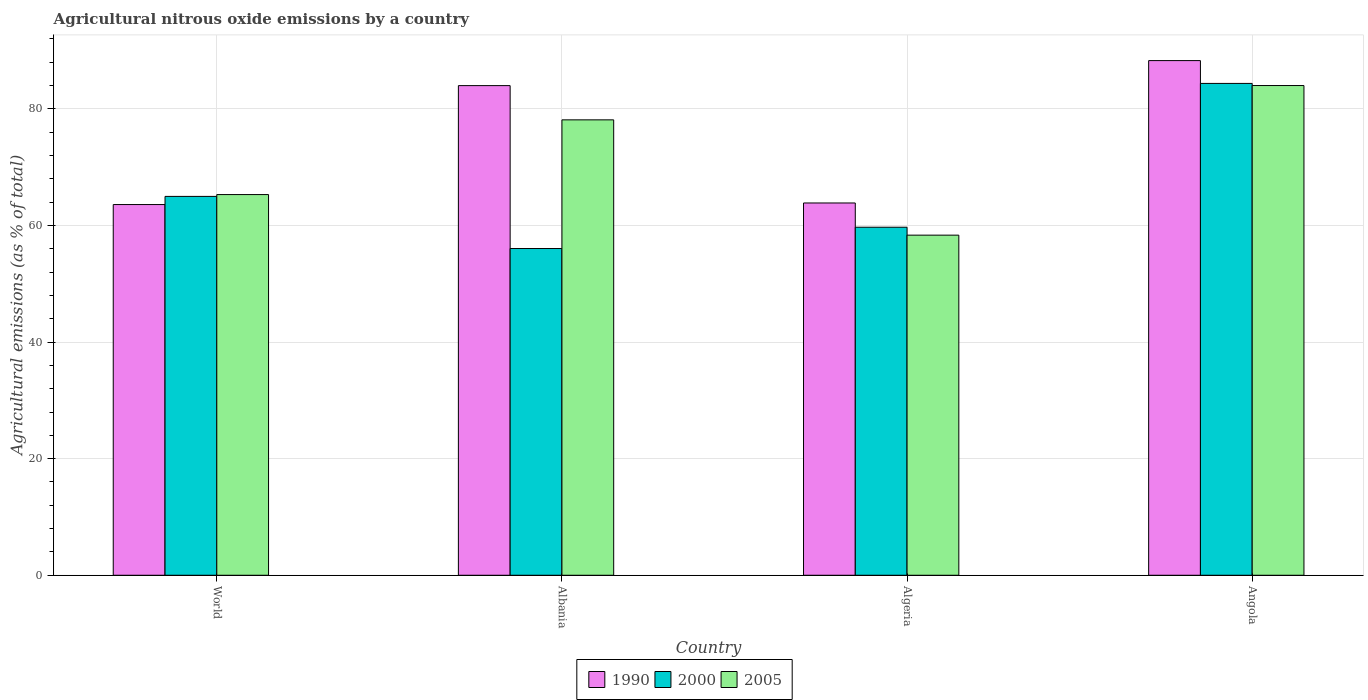How many different coloured bars are there?
Offer a terse response. 3. How many bars are there on the 4th tick from the left?
Provide a succinct answer. 3. What is the label of the 1st group of bars from the left?
Provide a short and direct response. World. What is the amount of agricultural nitrous oxide emitted in 2005 in World?
Make the answer very short. 65.29. Across all countries, what is the maximum amount of agricultural nitrous oxide emitted in 2005?
Provide a short and direct response. 83.99. Across all countries, what is the minimum amount of agricultural nitrous oxide emitted in 2000?
Provide a succinct answer. 56.04. In which country was the amount of agricultural nitrous oxide emitted in 1990 maximum?
Your answer should be compact. Angola. In which country was the amount of agricultural nitrous oxide emitted in 2005 minimum?
Provide a short and direct response. Algeria. What is the total amount of agricultural nitrous oxide emitted in 2000 in the graph?
Your answer should be compact. 265.07. What is the difference between the amount of agricultural nitrous oxide emitted in 2000 in Albania and that in Angola?
Give a very brief answer. -28.32. What is the difference between the amount of agricultural nitrous oxide emitted in 2005 in World and the amount of agricultural nitrous oxide emitted in 1990 in Albania?
Offer a terse response. -18.68. What is the average amount of agricultural nitrous oxide emitted in 2000 per country?
Provide a succinct answer. 66.27. What is the difference between the amount of agricultural nitrous oxide emitted of/in 2000 and amount of agricultural nitrous oxide emitted of/in 2005 in Algeria?
Offer a very short reply. 1.36. In how many countries, is the amount of agricultural nitrous oxide emitted in 2000 greater than 28 %?
Offer a terse response. 4. What is the ratio of the amount of agricultural nitrous oxide emitted in 1990 in Angola to that in World?
Provide a succinct answer. 1.39. What is the difference between the highest and the second highest amount of agricultural nitrous oxide emitted in 2005?
Make the answer very short. -18.7. What is the difference between the highest and the lowest amount of agricultural nitrous oxide emitted in 2000?
Ensure brevity in your answer.  28.32. In how many countries, is the amount of agricultural nitrous oxide emitted in 2005 greater than the average amount of agricultural nitrous oxide emitted in 2005 taken over all countries?
Your answer should be very brief. 2. Is it the case that in every country, the sum of the amount of agricultural nitrous oxide emitted in 2005 and amount of agricultural nitrous oxide emitted in 1990 is greater than the amount of agricultural nitrous oxide emitted in 2000?
Provide a succinct answer. Yes. Are all the bars in the graph horizontal?
Your answer should be compact. No. Are the values on the major ticks of Y-axis written in scientific E-notation?
Keep it short and to the point. No. How are the legend labels stacked?
Make the answer very short. Horizontal. What is the title of the graph?
Make the answer very short. Agricultural nitrous oxide emissions by a country. What is the label or title of the Y-axis?
Give a very brief answer. Agricultural emissions (as % of total). What is the Agricultural emissions (as % of total) in 1990 in World?
Make the answer very short. 63.58. What is the Agricultural emissions (as % of total) in 2000 in World?
Ensure brevity in your answer.  64.98. What is the Agricultural emissions (as % of total) in 2005 in World?
Give a very brief answer. 65.29. What is the Agricultural emissions (as % of total) in 1990 in Albania?
Offer a terse response. 83.98. What is the Agricultural emissions (as % of total) in 2000 in Albania?
Ensure brevity in your answer.  56.04. What is the Agricultural emissions (as % of total) of 2005 in Albania?
Make the answer very short. 78.11. What is the Agricultural emissions (as % of total) of 1990 in Algeria?
Make the answer very short. 63.85. What is the Agricultural emissions (as % of total) of 2000 in Algeria?
Ensure brevity in your answer.  59.69. What is the Agricultural emissions (as % of total) in 2005 in Algeria?
Offer a very short reply. 58.33. What is the Agricultural emissions (as % of total) of 1990 in Angola?
Your response must be concise. 88.27. What is the Agricultural emissions (as % of total) in 2000 in Angola?
Provide a succinct answer. 84.36. What is the Agricultural emissions (as % of total) in 2005 in Angola?
Provide a short and direct response. 83.99. Across all countries, what is the maximum Agricultural emissions (as % of total) in 1990?
Make the answer very short. 88.27. Across all countries, what is the maximum Agricultural emissions (as % of total) of 2000?
Your answer should be very brief. 84.36. Across all countries, what is the maximum Agricultural emissions (as % of total) in 2005?
Keep it short and to the point. 83.99. Across all countries, what is the minimum Agricultural emissions (as % of total) of 1990?
Provide a succinct answer. 63.58. Across all countries, what is the minimum Agricultural emissions (as % of total) of 2000?
Ensure brevity in your answer.  56.04. Across all countries, what is the minimum Agricultural emissions (as % of total) in 2005?
Your answer should be compact. 58.33. What is the total Agricultural emissions (as % of total) of 1990 in the graph?
Your response must be concise. 299.68. What is the total Agricultural emissions (as % of total) of 2000 in the graph?
Your answer should be compact. 265.07. What is the total Agricultural emissions (as % of total) of 2005 in the graph?
Ensure brevity in your answer.  285.73. What is the difference between the Agricultural emissions (as % of total) in 1990 in World and that in Albania?
Keep it short and to the point. -20.4. What is the difference between the Agricultural emissions (as % of total) of 2000 in World and that in Albania?
Make the answer very short. 8.94. What is the difference between the Agricultural emissions (as % of total) of 2005 in World and that in Albania?
Make the answer very short. -12.81. What is the difference between the Agricultural emissions (as % of total) of 1990 in World and that in Algeria?
Your response must be concise. -0.27. What is the difference between the Agricultural emissions (as % of total) in 2000 in World and that in Algeria?
Provide a succinct answer. 5.29. What is the difference between the Agricultural emissions (as % of total) of 2005 in World and that in Algeria?
Provide a succinct answer. 6.96. What is the difference between the Agricultural emissions (as % of total) of 1990 in World and that in Angola?
Give a very brief answer. -24.69. What is the difference between the Agricultural emissions (as % of total) in 2000 in World and that in Angola?
Keep it short and to the point. -19.38. What is the difference between the Agricultural emissions (as % of total) of 2005 in World and that in Angola?
Provide a short and direct response. -18.7. What is the difference between the Agricultural emissions (as % of total) of 1990 in Albania and that in Algeria?
Make the answer very short. 20.13. What is the difference between the Agricultural emissions (as % of total) in 2000 in Albania and that in Algeria?
Make the answer very short. -3.65. What is the difference between the Agricultural emissions (as % of total) in 2005 in Albania and that in Algeria?
Your answer should be compact. 19.77. What is the difference between the Agricultural emissions (as % of total) in 1990 in Albania and that in Angola?
Your response must be concise. -4.29. What is the difference between the Agricultural emissions (as % of total) of 2000 in Albania and that in Angola?
Make the answer very short. -28.32. What is the difference between the Agricultural emissions (as % of total) of 2005 in Albania and that in Angola?
Your answer should be very brief. -5.89. What is the difference between the Agricultural emissions (as % of total) in 1990 in Algeria and that in Angola?
Offer a very short reply. -24.42. What is the difference between the Agricultural emissions (as % of total) of 2000 in Algeria and that in Angola?
Offer a very short reply. -24.67. What is the difference between the Agricultural emissions (as % of total) of 2005 in Algeria and that in Angola?
Make the answer very short. -25.66. What is the difference between the Agricultural emissions (as % of total) of 1990 in World and the Agricultural emissions (as % of total) of 2000 in Albania?
Your response must be concise. 7.54. What is the difference between the Agricultural emissions (as % of total) in 1990 in World and the Agricultural emissions (as % of total) in 2005 in Albania?
Offer a terse response. -14.53. What is the difference between the Agricultural emissions (as % of total) of 2000 in World and the Agricultural emissions (as % of total) of 2005 in Albania?
Make the answer very short. -13.13. What is the difference between the Agricultural emissions (as % of total) of 1990 in World and the Agricultural emissions (as % of total) of 2000 in Algeria?
Provide a succinct answer. 3.89. What is the difference between the Agricultural emissions (as % of total) in 1990 in World and the Agricultural emissions (as % of total) in 2005 in Algeria?
Give a very brief answer. 5.25. What is the difference between the Agricultural emissions (as % of total) in 2000 in World and the Agricultural emissions (as % of total) in 2005 in Algeria?
Offer a terse response. 6.65. What is the difference between the Agricultural emissions (as % of total) in 1990 in World and the Agricultural emissions (as % of total) in 2000 in Angola?
Provide a succinct answer. -20.78. What is the difference between the Agricultural emissions (as % of total) of 1990 in World and the Agricultural emissions (as % of total) of 2005 in Angola?
Provide a succinct answer. -20.41. What is the difference between the Agricultural emissions (as % of total) in 2000 in World and the Agricultural emissions (as % of total) in 2005 in Angola?
Ensure brevity in your answer.  -19.01. What is the difference between the Agricultural emissions (as % of total) of 1990 in Albania and the Agricultural emissions (as % of total) of 2000 in Algeria?
Offer a terse response. 24.29. What is the difference between the Agricultural emissions (as % of total) of 1990 in Albania and the Agricultural emissions (as % of total) of 2005 in Algeria?
Keep it short and to the point. 25.65. What is the difference between the Agricultural emissions (as % of total) of 2000 in Albania and the Agricultural emissions (as % of total) of 2005 in Algeria?
Offer a terse response. -2.29. What is the difference between the Agricultural emissions (as % of total) in 1990 in Albania and the Agricultural emissions (as % of total) in 2000 in Angola?
Offer a terse response. -0.38. What is the difference between the Agricultural emissions (as % of total) of 1990 in Albania and the Agricultural emissions (as % of total) of 2005 in Angola?
Your answer should be very brief. -0.01. What is the difference between the Agricultural emissions (as % of total) in 2000 in Albania and the Agricultural emissions (as % of total) in 2005 in Angola?
Offer a terse response. -27.95. What is the difference between the Agricultural emissions (as % of total) of 1990 in Algeria and the Agricultural emissions (as % of total) of 2000 in Angola?
Your answer should be very brief. -20.51. What is the difference between the Agricultural emissions (as % of total) in 1990 in Algeria and the Agricultural emissions (as % of total) in 2005 in Angola?
Give a very brief answer. -20.14. What is the difference between the Agricultural emissions (as % of total) in 2000 in Algeria and the Agricultural emissions (as % of total) in 2005 in Angola?
Your response must be concise. -24.3. What is the average Agricultural emissions (as % of total) in 1990 per country?
Provide a succinct answer. 74.92. What is the average Agricultural emissions (as % of total) in 2000 per country?
Give a very brief answer. 66.27. What is the average Agricultural emissions (as % of total) in 2005 per country?
Give a very brief answer. 71.43. What is the difference between the Agricultural emissions (as % of total) of 1990 and Agricultural emissions (as % of total) of 2000 in World?
Provide a succinct answer. -1.4. What is the difference between the Agricultural emissions (as % of total) of 1990 and Agricultural emissions (as % of total) of 2005 in World?
Make the answer very short. -1.71. What is the difference between the Agricultural emissions (as % of total) of 2000 and Agricultural emissions (as % of total) of 2005 in World?
Your answer should be compact. -0.31. What is the difference between the Agricultural emissions (as % of total) in 1990 and Agricultural emissions (as % of total) in 2000 in Albania?
Provide a short and direct response. 27.94. What is the difference between the Agricultural emissions (as % of total) of 1990 and Agricultural emissions (as % of total) of 2005 in Albania?
Provide a short and direct response. 5.87. What is the difference between the Agricultural emissions (as % of total) in 2000 and Agricultural emissions (as % of total) in 2005 in Albania?
Provide a short and direct response. -22.07. What is the difference between the Agricultural emissions (as % of total) in 1990 and Agricultural emissions (as % of total) in 2000 in Algeria?
Keep it short and to the point. 4.16. What is the difference between the Agricultural emissions (as % of total) in 1990 and Agricultural emissions (as % of total) in 2005 in Algeria?
Your answer should be very brief. 5.52. What is the difference between the Agricultural emissions (as % of total) in 2000 and Agricultural emissions (as % of total) in 2005 in Algeria?
Give a very brief answer. 1.36. What is the difference between the Agricultural emissions (as % of total) in 1990 and Agricultural emissions (as % of total) in 2000 in Angola?
Provide a short and direct response. 3.91. What is the difference between the Agricultural emissions (as % of total) in 1990 and Agricultural emissions (as % of total) in 2005 in Angola?
Your answer should be compact. 4.28. What is the difference between the Agricultural emissions (as % of total) in 2000 and Agricultural emissions (as % of total) in 2005 in Angola?
Your answer should be very brief. 0.37. What is the ratio of the Agricultural emissions (as % of total) of 1990 in World to that in Albania?
Your answer should be compact. 0.76. What is the ratio of the Agricultural emissions (as % of total) of 2000 in World to that in Albania?
Make the answer very short. 1.16. What is the ratio of the Agricultural emissions (as % of total) of 2005 in World to that in Albania?
Your answer should be compact. 0.84. What is the ratio of the Agricultural emissions (as % of total) of 2000 in World to that in Algeria?
Your answer should be compact. 1.09. What is the ratio of the Agricultural emissions (as % of total) of 2005 in World to that in Algeria?
Provide a succinct answer. 1.12. What is the ratio of the Agricultural emissions (as % of total) in 1990 in World to that in Angola?
Your response must be concise. 0.72. What is the ratio of the Agricultural emissions (as % of total) in 2000 in World to that in Angola?
Provide a short and direct response. 0.77. What is the ratio of the Agricultural emissions (as % of total) in 2005 in World to that in Angola?
Provide a succinct answer. 0.78. What is the ratio of the Agricultural emissions (as % of total) of 1990 in Albania to that in Algeria?
Make the answer very short. 1.32. What is the ratio of the Agricultural emissions (as % of total) of 2000 in Albania to that in Algeria?
Your response must be concise. 0.94. What is the ratio of the Agricultural emissions (as % of total) in 2005 in Albania to that in Algeria?
Your response must be concise. 1.34. What is the ratio of the Agricultural emissions (as % of total) of 1990 in Albania to that in Angola?
Provide a succinct answer. 0.95. What is the ratio of the Agricultural emissions (as % of total) of 2000 in Albania to that in Angola?
Give a very brief answer. 0.66. What is the ratio of the Agricultural emissions (as % of total) of 2005 in Albania to that in Angola?
Offer a very short reply. 0.93. What is the ratio of the Agricultural emissions (as % of total) of 1990 in Algeria to that in Angola?
Give a very brief answer. 0.72. What is the ratio of the Agricultural emissions (as % of total) in 2000 in Algeria to that in Angola?
Your answer should be very brief. 0.71. What is the ratio of the Agricultural emissions (as % of total) in 2005 in Algeria to that in Angola?
Your answer should be very brief. 0.69. What is the difference between the highest and the second highest Agricultural emissions (as % of total) in 1990?
Your answer should be compact. 4.29. What is the difference between the highest and the second highest Agricultural emissions (as % of total) of 2000?
Keep it short and to the point. 19.38. What is the difference between the highest and the second highest Agricultural emissions (as % of total) of 2005?
Your answer should be very brief. 5.89. What is the difference between the highest and the lowest Agricultural emissions (as % of total) in 1990?
Make the answer very short. 24.69. What is the difference between the highest and the lowest Agricultural emissions (as % of total) of 2000?
Give a very brief answer. 28.32. What is the difference between the highest and the lowest Agricultural emissions (as % of total) in 2005?
Your answer should be compact. 25.66. 